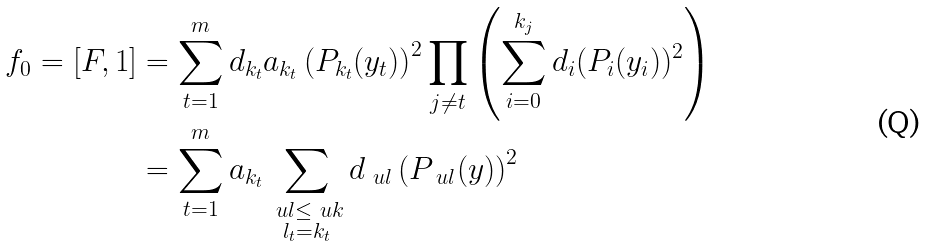<formula> <loc_0><loc_0><loc_500><loc_500>f _ { 0 } = [ F , 1 ] & = \sum _ { t = 1 } ^ { m } d _ { k _ { t } } a _ { k _ { t } } \left ( P _ { k _ { t } } ( y _ { t } ) \right ) ^ { 2 } \prod _ { j \neq t } \left ( \sum _ { i = 0 } ^ { k _ { j } } d _ { i } ( P _ { i } ( y _ { i } ) ) ^ { 2 } \right ) \\ & = \sum _ { t = 1 } ^ { m } a _ { k _ { t } } \sum _ { \substack { \ u l \leq \ u k \\ l _ { t } = k _ { t } } } d _ { \ u l } \left ( P _ { \ u l } ( y ) \right ) ^ { 2 }</formula> 